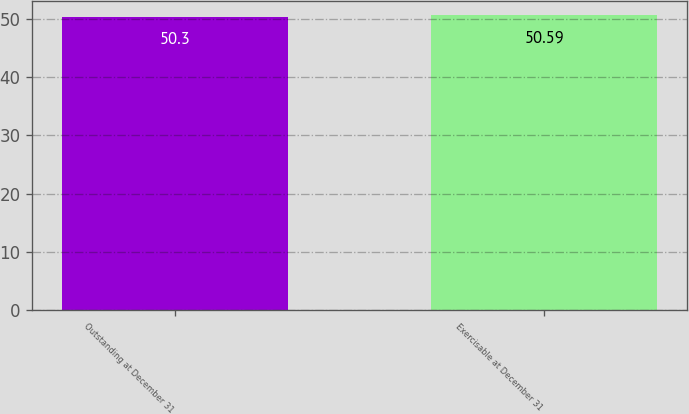<chart> <loc_0><loc_0><loc_500><loc_500><bar_chart><fcel>Outstanding at December 31<fcel>Exercisable at December 31<nl><fcel>50.3<fcel>50.59<nl></chart> 